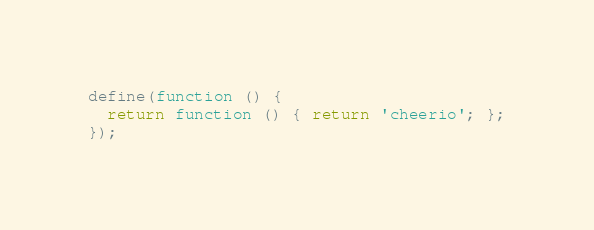Convert code to text. <code><loc_0><loc_0><loc_500><loc_500><_JavaScript_>define(function () {
  return function () { return 'cheerio'; };
});
</code> 